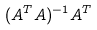<formula> <loc_0><loc_0><loc_500><loc_500>( A ^ { T } A ) ^ { - 1 } A ^ { T }</formula> 